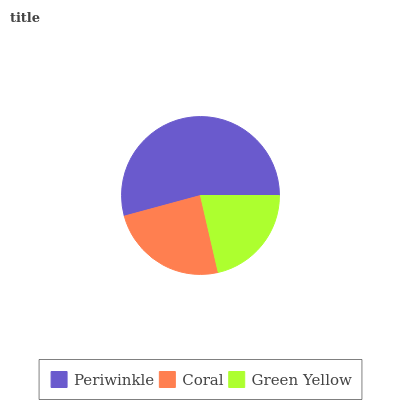Is Green Yellow the minimum?
Answer yes or no. Yes. Is Periwinkle the maximum?
Answer yes or no. Yes. Is Coral the minimum?
Answer yes or no. No. Is Coral the maximum?
Answer yes or no. No. Is Periwinkle greater than Coral?
Answer yes or no. Yes. Is Coral less than Periwinkle?
Answer yes or no. Yes. Is Coral greater than Periwinkle?
Answer yes or no. No. Is Periwinkle less than Coral?
Answer yes or no. No. Is Coral the high median?
Answer yes or no. Yes. Is Coral the low median?
Answer yes or no. Yes. Is Periwinkle the high median?
Answer yes or no. No. Is Green Yellow the low median?
Answer yes or no. No. 